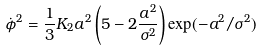Convert formula to latex. <formula><loc_0><loc_0><loc_500><loc_500>\dot { \phi } ^ { 2 } = \frac { 1 } { 3 } K _ { 2 } a ^ { 2 } \left ( 5 - 2 \frac { a ^ { 2 } } { \sigma ^ { 2 } } \right ) \exp ( - a ^ { 2 } / \sigma ^ { 2 } ) \</formula> 